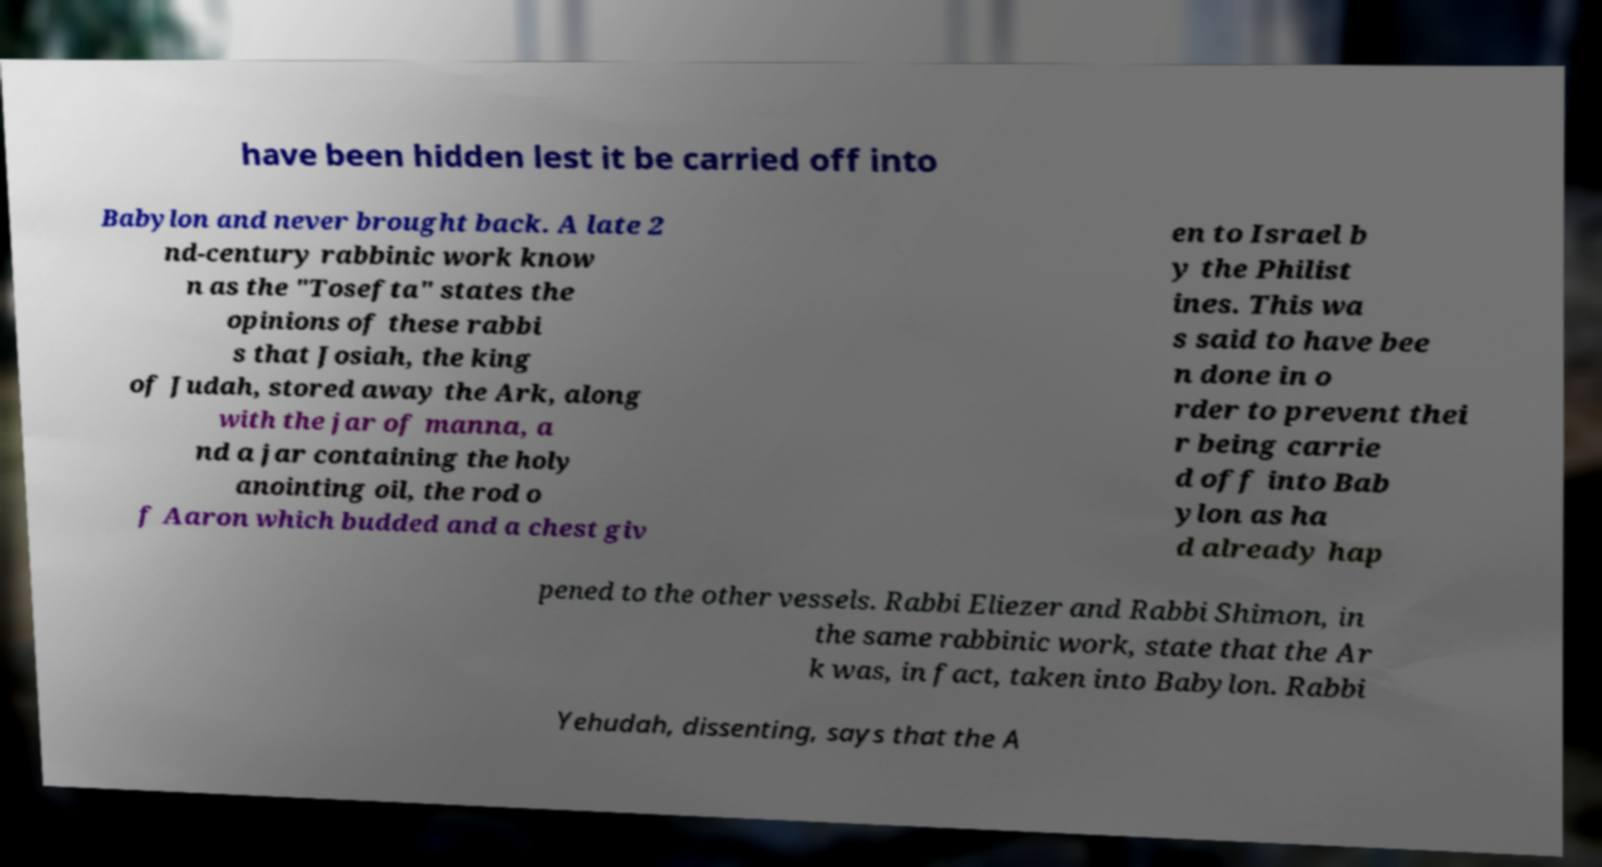For documentation purposes, I need the text within this image transcribed. Could you provide that? have been hidden lest it be carried off into Babylon and never brought back. A late 2 nd-century rabbinic work know n as the "Tosefta" states the opinions of these rabbi s that Josiah, the king of Judah, stored away the Ark, along with the jar of manna, a nd a jar containing the holy anointing oil, the rod o f Aaron which budded and a chest giv en to Israel b y the Philist ines. This wa s said to have bee n done in o rder to prevent thei r being carrie d off into Bab ylon as ha d already hap pened to the other vessels. Rabbi Eliezer and Rabbi Shimon, in the same rabbinic work, state that the Ar k was, in fact, taken into Babylon. Rabbi Yehudah, dissenting, says that the A 